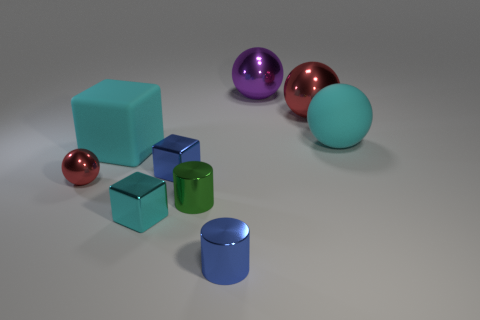Is there another cyan thing made of the same material as the small cyan object?
Provide a short and direct response. No. There is a red sphere in front of the cyan sphere; what is its material?
Offer a terse response. Metal. Does the tiny cylinder on the right side of the small green cylinder have the same color as the sphere that is on the left side of the purple ball?
Your answer should be very brief. No. There is another shiny cylinder that is the same size as the green cylinder; what color is it?
Provide a short and direct response. Blue. How many other objects are there of the same shape as the cyan shiny object?
Ensure brevity in your answer.  2. What size is the red metallic object that is to the right of the green thing?
Make the answer very short. Large. How many tiny blue cylinders are behind the red thing that is behind the cyan rubber sphere?
Offer a very short reply. 0. What number of other things are the same size as the cyan metal cube?
Provide a short and direct response. 4. Do the small ball and the matte block have the same color?
Your response must be concise. No. There is a object that is on the left side of the large cyan block; is it the same shape as the big purple object?
Make the answer very short. Yes. 